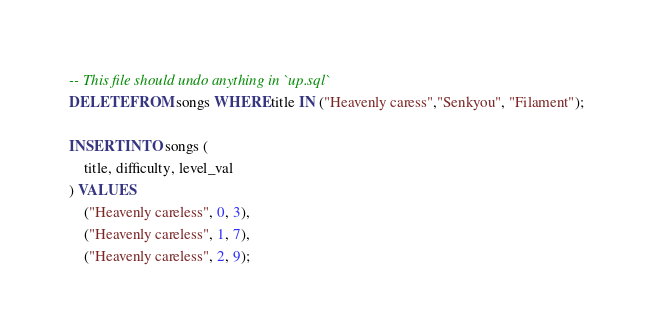<code> <loc_0><loc_0><loc_500><loc_500><_SQL_>-- This file should undo anything in `up.sql`
DELETE FROM songs WHERE title IN ("Heavenly caress","Senkyou", "Filament");

INSERT INTO songs (
    title, difficulty, level_val
) VALUES 
    ("Heavenly careless", 0, 3),
    ("Heavenly careless", 1, 7),
    ("Heavenly careless", 2, 9);
</code> 